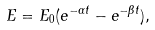<formula> <loc_0><loc_0><loc_500><loc_500>E = E _ { 0 } ( e ^ { - \alpha t } - e ^ { - \beta t } ) ,</formula> 